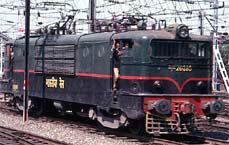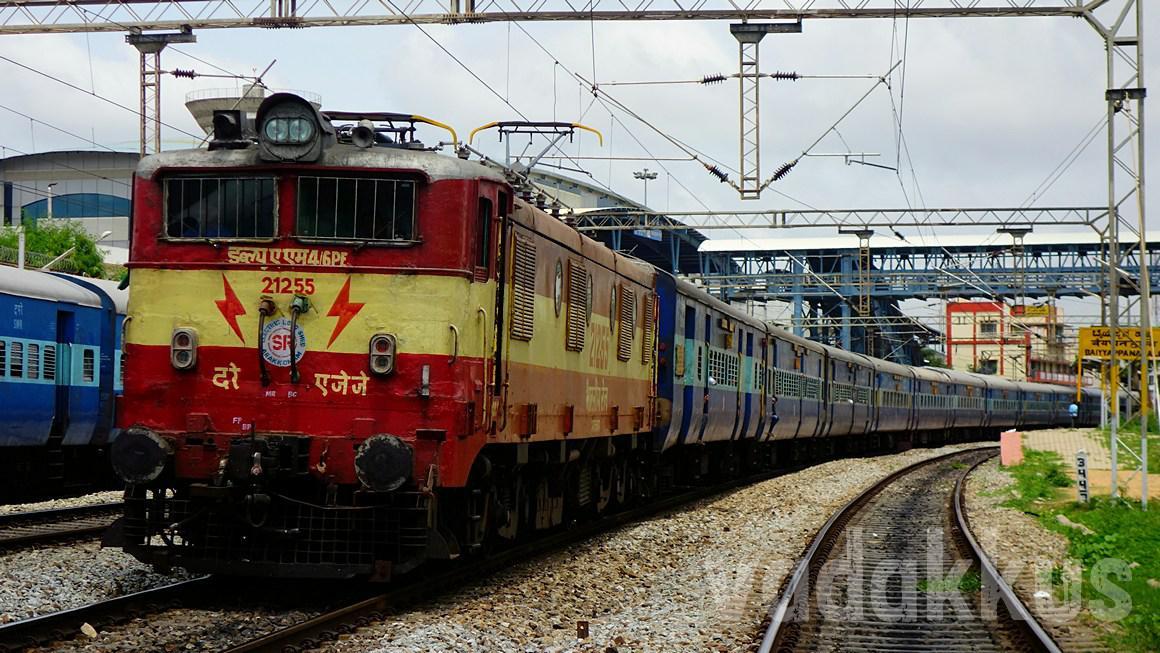The first image is the image on the left, the second image is the image on the right. Given the left and right images, does the statement "All of the trains are electric." hold true? Answer yes or no. No. 